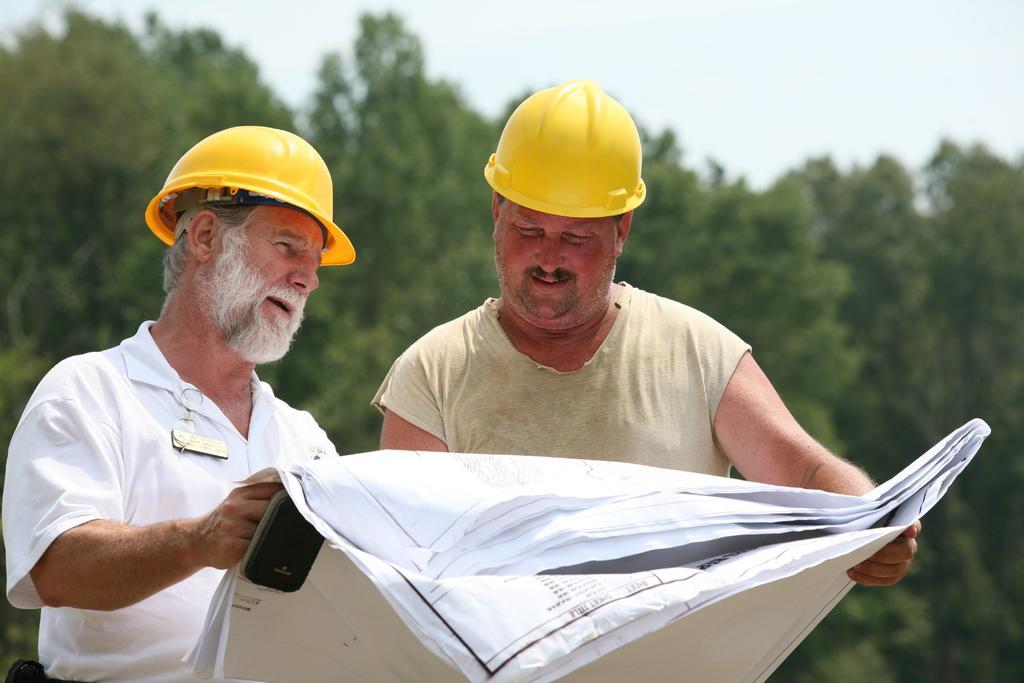Please provide a concise description of this image. In this image I can see a person wearing white colored shirt and another person wearing cream colored shirt and yellow colored helmets are standing and holding papers in their hands. In the background I can see few trees and the sky. 